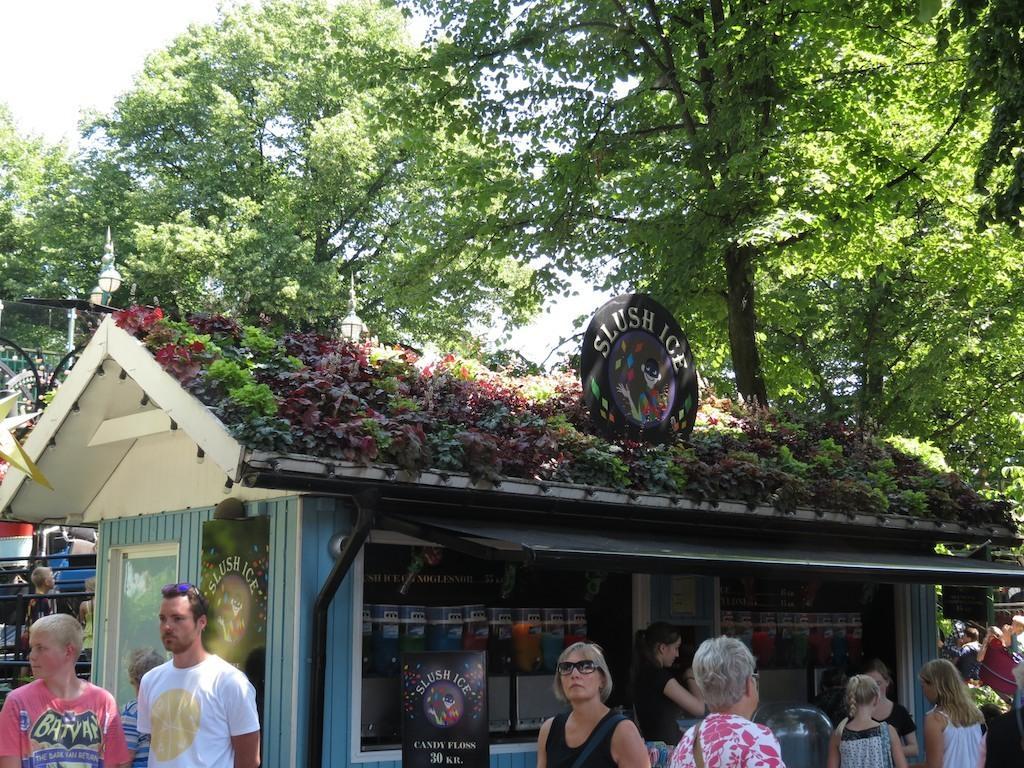Describe this image in one or two sentences. At the bottom of the picture, we see people standing. Beside them, we see a black color board with text written on it. Beside that, we see a shop in blue color. There are trees and street lights in the background. On the left side, we see an iron railing. This picture might be clicked in the park. 